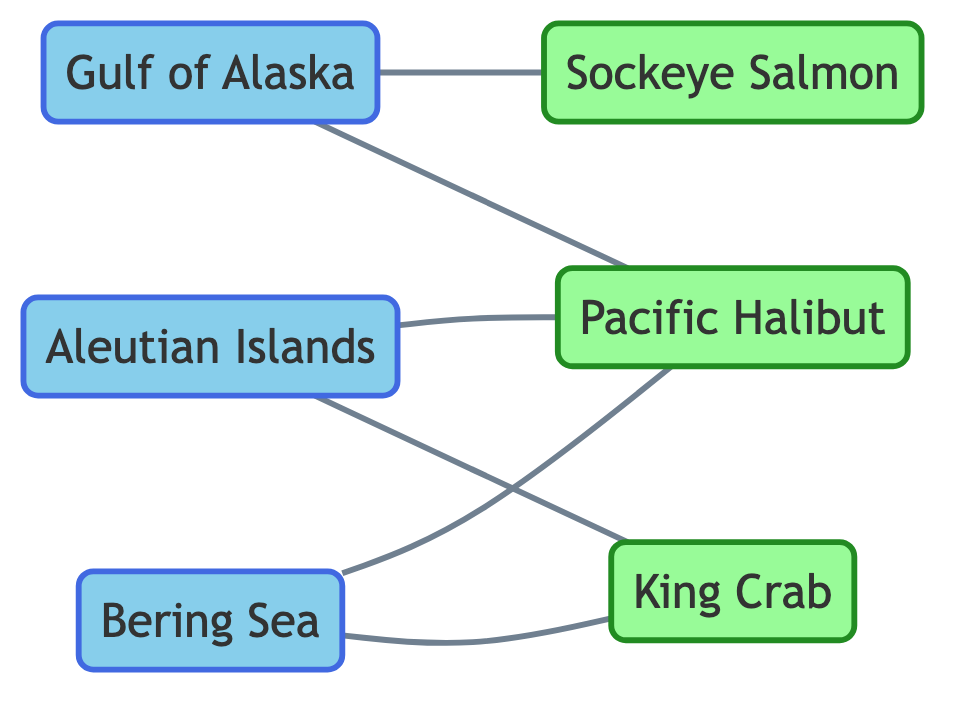What are the fishing routes depicted in the diagram? The nodes labeled as "Fishing Route" indicate the fishing routes shown in the diagram: Gulf of Alaska, Bering Sea, and Aleutian Islands.
Answer: Gulf of Alaska, Bering Sea, Aleutian Islands Which marine life is sighted in the Gulf of Alaska? The edges connected to the Gulf of Alaska node show two sightings: Pacific Halibut and Sockeye Salmon, which are indicated by the relationships in the diagram.
Answer: Pacific Halibut, Sockeye Salmon How many marine life types are represented in the diagram? The nodes labeled as "Marine Life" indicate the types of marine life. In total, there are three types shown: Pacific Halibut, King Crab, and Sockeye Salmon.
Answer: 3 Which fishing routes are associated with King Crab sightings? By examining the edges connected to the King Crab node, it can be determined that there are two fishing routes associated with King Crab sightings: Bering Sea and Aleutian Islands.
Answer: Bering Sea, Aleutian Islands What is the total number of edges in the diagram? Each edge represents a sighting relationship between fishing routes and marine life. By counting all the connections, there are six edges displayed in the diagram.
Answer: 6 Which marine life is sighted in both Bering Sea and Aleutian Islands fishing routes? The edges connected to both the Bering Sea and Aleutian Islands nodes show Pacific Halibut as the common marine life sighted in both fishing routes.
Answer: Pacific Halibut Are there any fishing routes that do not have associated marine life in this diagram? By reviewing each fishing route node, it's clear from the edges that all three fishing routes have at least one marine life associated with them, confirming no fishing routes are without sightings.
Answer: No How many relationships are recorded for the Aleutian Islands fishing route? The edges originating from the Aleutian Islands node illustrate two relationships representing sightings of King Crab and Pacific Halibut.
Answer: 2 